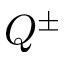<formula> <loc_0><loc_0><loc_500><loc_500>Q ^ { \pm }</formula> 